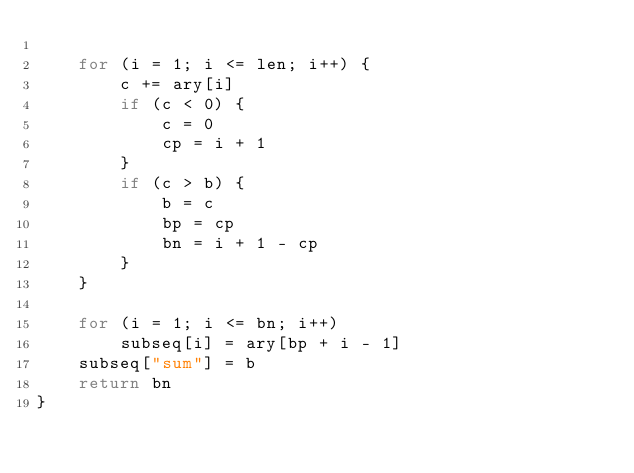<code> <loc_0><loc_0><loc_500><loc_500><_Awk_>
	for (i = 1; i <= len; i++) {
		c += ary[i]
		if (c < 0) {
			c = 0
			cp = i + 1
		}
		if (c > b) {
			b = c
			bp = cp
			bn = i + 1 - cp
		}
	}

	for (i = 1; i <= bn; i++)
		subseq[i] = ary[bp + i - 1]
	subseq["sum"] = b
	return bn
}
</code> 